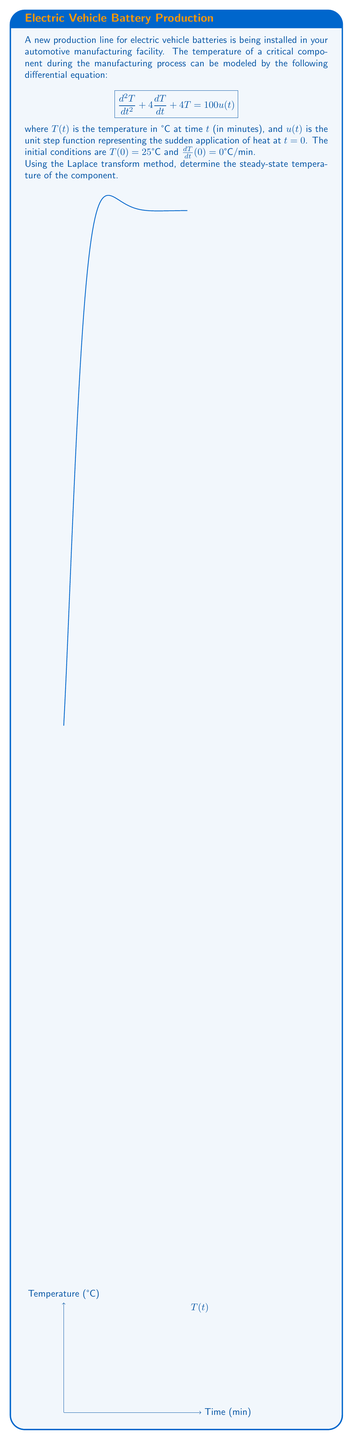Can you answer this question? Let's solve this problem step-by-step using the Laplace transform method:

1) First, let's take the Laplace transform of both sides of the differential equation:
   $$\mathcal{L}\{d^2T/dt^2 + 4dT/dt + 4T\} = \mathcal{L}\{100u(t)\}$$

2) Using Laplace transform properties:
   $$s^2T(s) - sT(0) - T'(0) + 4[sT(s) - T(0)] + 4T(s) = 100/s$$

3) Substituting the initial conditions $T(0) = 25$ and $T'(0) = 0$:
   $$s^2T(s) - 25s + 4sT(s) - 100 + 4T(s) = 100/s$$

4) Simplifying:
   $$(s^2 + 4s + 4)T(s) = 100/s + 25s + 100$$
   $$T(s) = \frac{100/s + 25s + 100}{s^2 + 4s + 4}$$

5) The denominator can be factored as $(s+2)^2$, so we have:
   $$T(s) = \frac{100/s + 25s + 100}{(s+2)^2}$$

6) To find the steady-state temperature, we need to apply the Final Value Theorem:
   $$T_{ss} = \lim_{t\to\infty} T(t) = \lim_{s\to0} sT(s)$$

7) Applying this to our expression for $T(s)$:
   $$T_{ss} = \lim_{s\to0} s\frac{100/s + 25s + 100}{(s+2)^2}$$

8) As $s$ approaches 0, the $25s$ term becomes negligible:
   $$T_{ss} = \lim_{s\to0} \frac{100 + 100s}{(s+2)^2} = \frac{100}{4} = 25$$

Thus, the steady-state temperature of the component is 25°C.
Answer: 25°C 